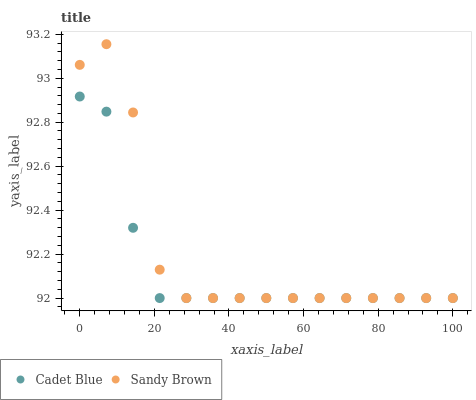Does Cadet Blue have the minimum area under the curve?
Answer yes or no. Yes. Does Sandy Brown have the maximum area under the curve?
Answer yes or no. Yes. Does Sandy Brown have the minimum area under the curve?
Answer yes or no. No. Is Cadet Blue the smoothest?
Answer yes or no. Yes. Is Sandy Brown the roughest?
Answer yes or no. Yes. Is Sandy Brown the smoothest?
Answer yes or no. No. Does Cadet Blue have the lowest value?
Answer yes or no. Yes. Does Sandy Brown have the highest value?
Answer yes or no. Yes. Does Sandy Brown intersect Cadet Blue?
Answer yes or no. Yes. Is Sandy Brown less than Cadet Blue?
Answer yes or no. No. Is Sandy Brown greater than Cadet Blue?
Answer yes or no. No. 